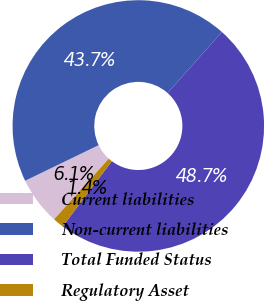Convert chart. <chart><loc_0><loc_0><loc_500><loc_500><pie_chart><fcel>Current liabilities<fcel>Non-current liabilities<fcel>Total Funded Status<fcel>Regulatory Asset<nl><fcel>6.14%<fcel>43.75%<fcel>48.71%<fcel>1.41%<nl></chart> 